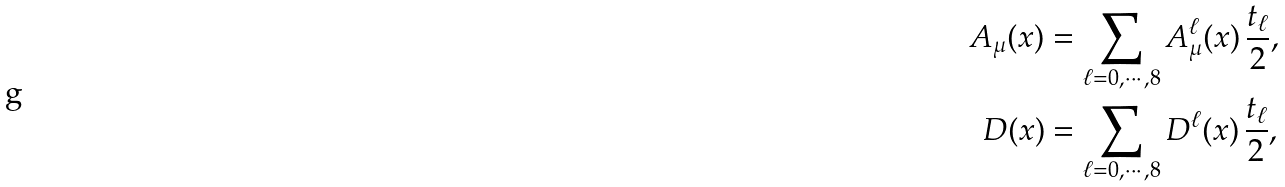Convert formula to latex. <formula><loc_0><loc_0><loc_500><loc_500>A _ { \mu } ( x ) & = \sum _ { \ell = 0 , \cdots , 8 } A _ { \mu } ^ { \ell } ( x ) \, \frac { t _ { \ell } } { 2 } , \\ D ( x ) & = \sum _ { \ell = 0 , \cdots , 8 } D ^ { \ell } ( x ) \, \frac { t _ { \ell } } { 2 } ,</formula> 